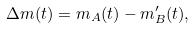<formula> <loc_0><loc_0><loc_500><loc_500>\Delta m ( t ) = m _ { A } ( t ) - m ^ { \prime } _ { B } ( t ) ,</formula> 